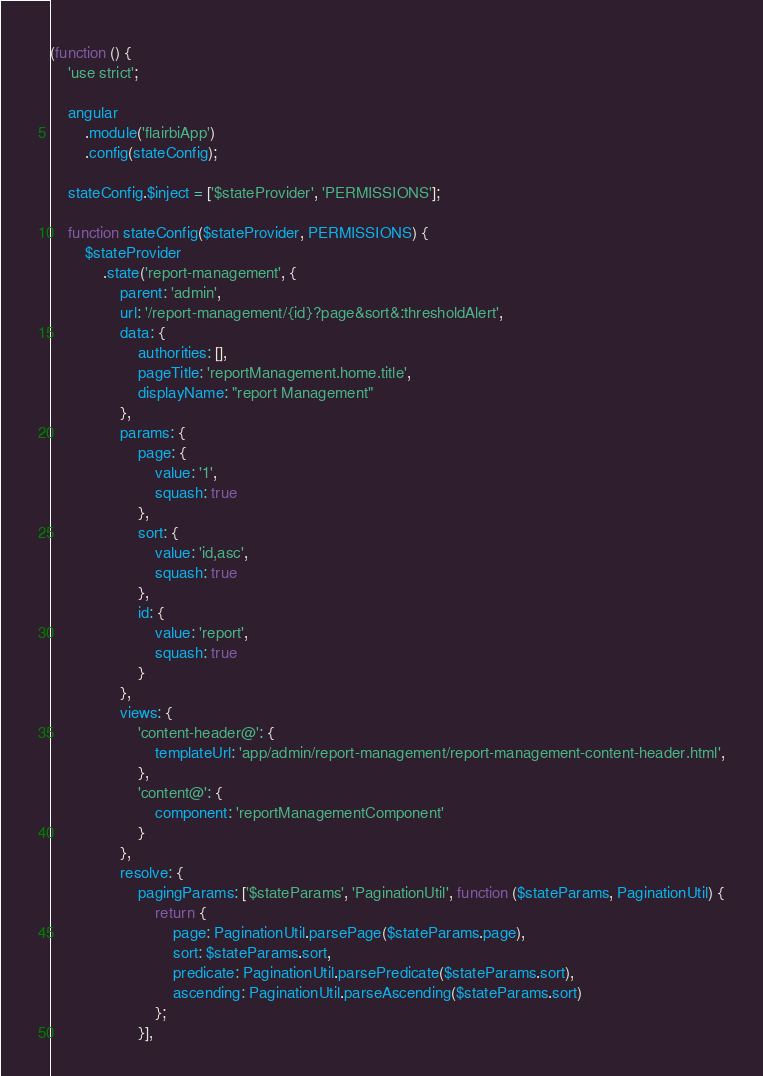Convert code to text. <code><loc_0><loc_0><loc_500><loc_500><_JavaScript_>(function () {
    'use strict';

    angular
        .module('flairbiApp')
        .config(stateConfig);

    stateConfig.$inject = ['$stateProvider', 'PERMISSIONS'];

    function stateConfig($stateProvider, PERMISSIONS) {
        $stateProvider
            .state('report-management', {
                parent: 'admin',
                url: '/report-management/{id}?page&sort&:thresholdAlert',
                data: {
                    authorities: [],
                    pageTitle: 'reportManagement.home.title',
                    displayName: "report Management"
                },
                params: {
                    page: {
                        value: '1',
                        squash: true
                    },
                    sort: {
                        value: 'id,asc',
                        squash: true
                    },
                    id: {
                        value: 'report',
                        squash: true
                    }
                },
                views: {
                    'content-header@': {
                        templateUrl: 'app/admin/report-management/report-management-content-header.html',
                    },
                    'content@': {
                        component: 'reportManagementComponent'
                    }
                },
                resolve: {
                    pagingParams: ['$stateParams', 'PaginationUtil', function ($stateParams, PaginationUtil) {
                        return {
                            page: PaginationUtil.parsePage($stateParams.page),
                            sort: $stateParams.sort,
                            predicate: PaginationUtil.parsePredicate($stateParams.sort),
                            ascending: PaginationUtil.parseAscending($stateParams.sort)
                        };
                    }],</code> 